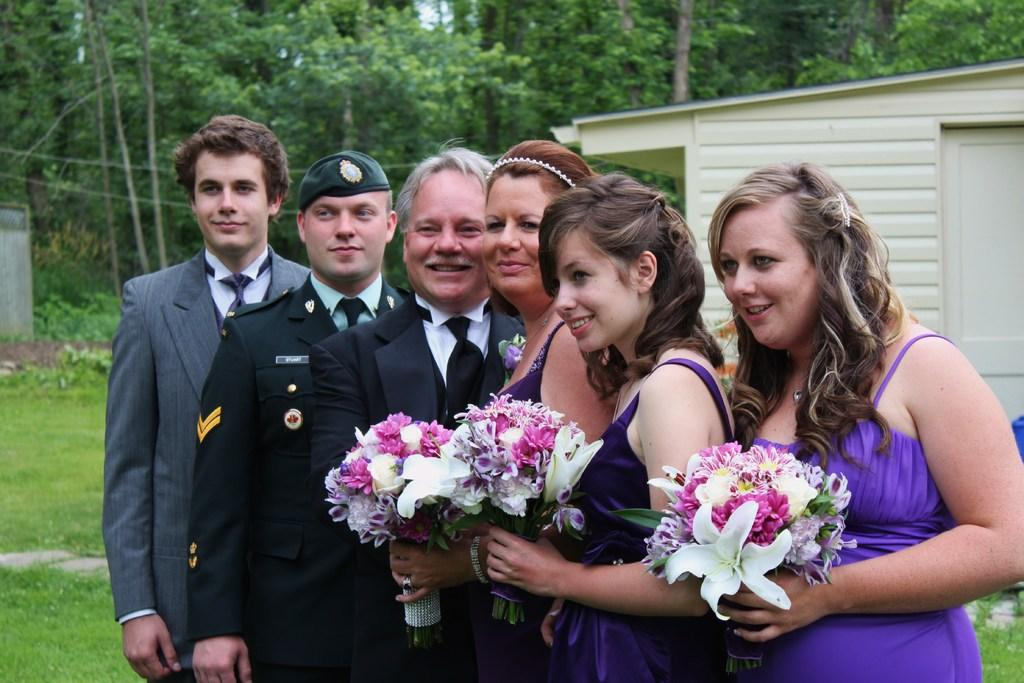What can be observed about the clothing of the people in the image? There are people with different color dresses in the image. What are some of the people holding in the image? Three people are holding flower bouquets. What can be seen in the background of the image? There is a house and many trees in the background of the image. What type of fruit is being taught in the image? There is no fruit or teaching activity present in the image. 